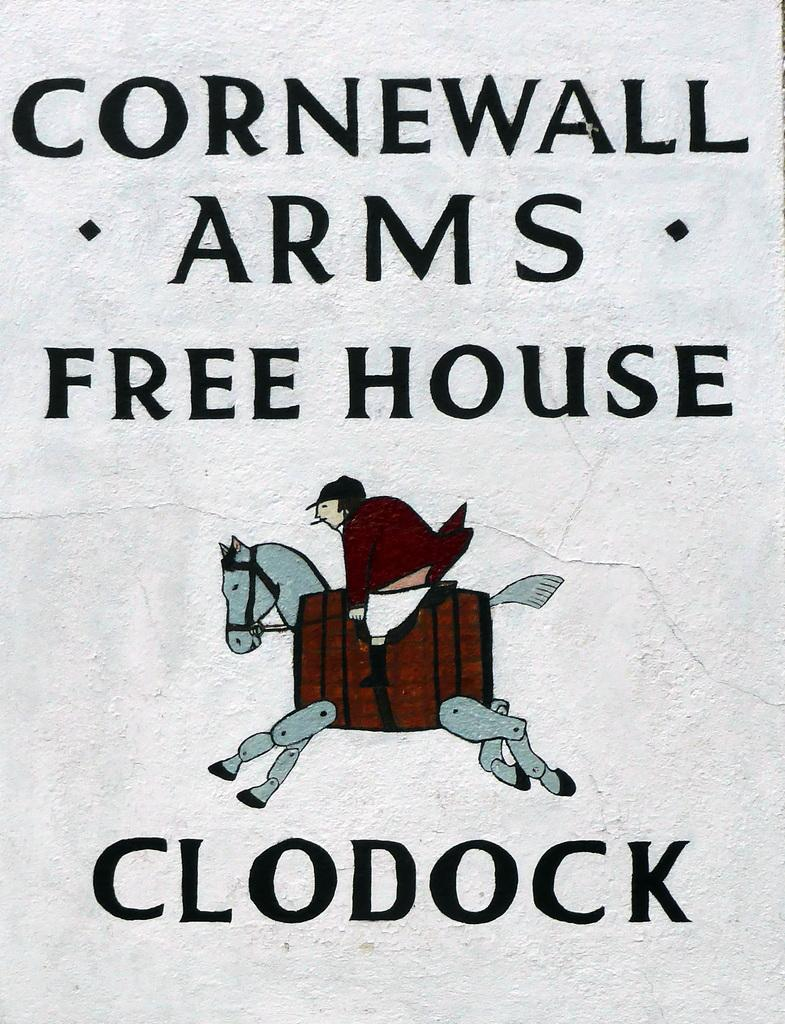What type of visual is the image? The image is a poster. What can be found on the poster besides the visual? There is text written on the poster. What activity is being depicted in the image? A person is riding a horse in the image. What type of magic is the person performing on the horse in the image? A: There is no magic being performed in the image; a person is simply riding a horse. What tools or equipment might the carpenter be using in the image? There is no carpenter present in the image, so it is not possible to determine what tools or equipment they might be using. 